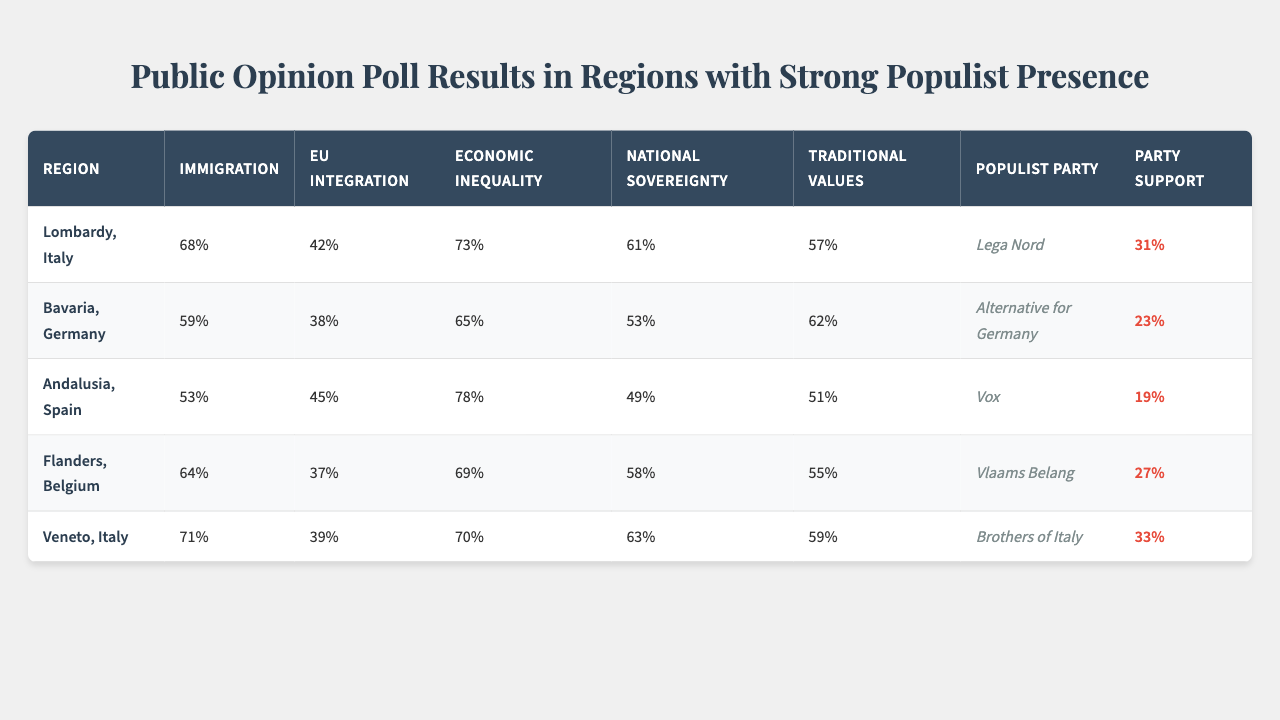What is the highest percentage of support for a populist party in the table? The highest percentage of support for a populist party is found in Lombardy, Italy, where it is 31%.
Answer: 31% Which region has the lowest percentage of support for the populist party? In Andalusia, Spain, the populist party support is the lowest at 19%.
Answer: 19% What is the average percentage of support for populist parties across all regions? To find the average support: (31 + 23 + 19 + 27 + 33) = 133; there are 5 regions, so the average support is 133/5 = 26.6%.
Answer: 26.6% Is there a region where the immigration percentage is above 70%? Yes, Lombardy and Veneto have immigration percentages of 68% and 71%, respectively, where Veneto is above 70%.
Answer: Yes Which region has the highest concern about economic inequality? Andalusia, Spain has the highest concern about economic inequality at 78%.
Answer: 78% If we compare Lombardy and Bavaria on national sovereignty, which region exhibits more concern? Lombardy shows a national sovereignty concern of 61%, while Bavaria shows a concern of 53%, meaning Lombardy has more concern.
Answer: Lombardy What is the difference in the immigration percentage between Veneto and Flanders? Veneto has an immigration percentage of 71%, and Flanders has 64%, so the difference is 71 - 64 = 7%.
Answer: 7% Which region values traditional values the least? Andalusia demonstrates the least value for traditional values at 51%.
Answer: 51% Do all regions have a populist party support percentage above 15%? Yes, all regions have populist party support percentages above 15%, with the lowest being 19% in Andalusia.
Answer: Yes Which demographic factor shows the strongest correlation with traditional values? The demographic factor that shows the strongest correlation with traditional values is age, with a correlation score of 0.71.
Answer: Age What is the correlation score for economic inequality concerning education level? The correlation score for economic inequality concerning education level is -0.45, indicating a negative relationship.
Answer: -0.45 